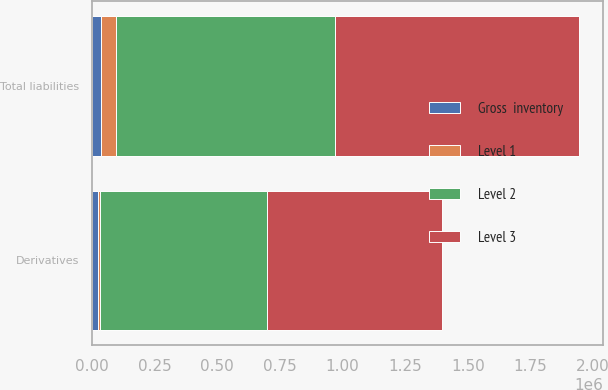Convert chart to OTSL. <chart><loc_0><loc_0><loc_500><loc_500><stacked_bar_chart><ecel><fcel>Derivatives<fcel>Total liabilities<nl><fcel>Level 1<fcel>4980<fcel>57379<nl><fcel>Level 2<fcel>669384<fcel>876270<nl><fcel>Gross  inventory<fcel>24577<fcel>37333<nl><fcel>Level 3<fcel>698941<fcel>970982<nl></chart> 